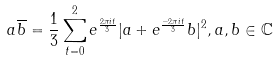<formula> <loc_0><loc_0><loc_500><loc_500>a \overline { b } = \frac { 1 } { 3 } \sum _ { t = 0 } ^ { 2 } e ^ { \frac { 2 \pi i t } { 3 } } | a + e ^ { \frac { - 2 \pi i t } { 3 } } b | ^ { 2 } , a , b \in \mathbb { C }</formula> 